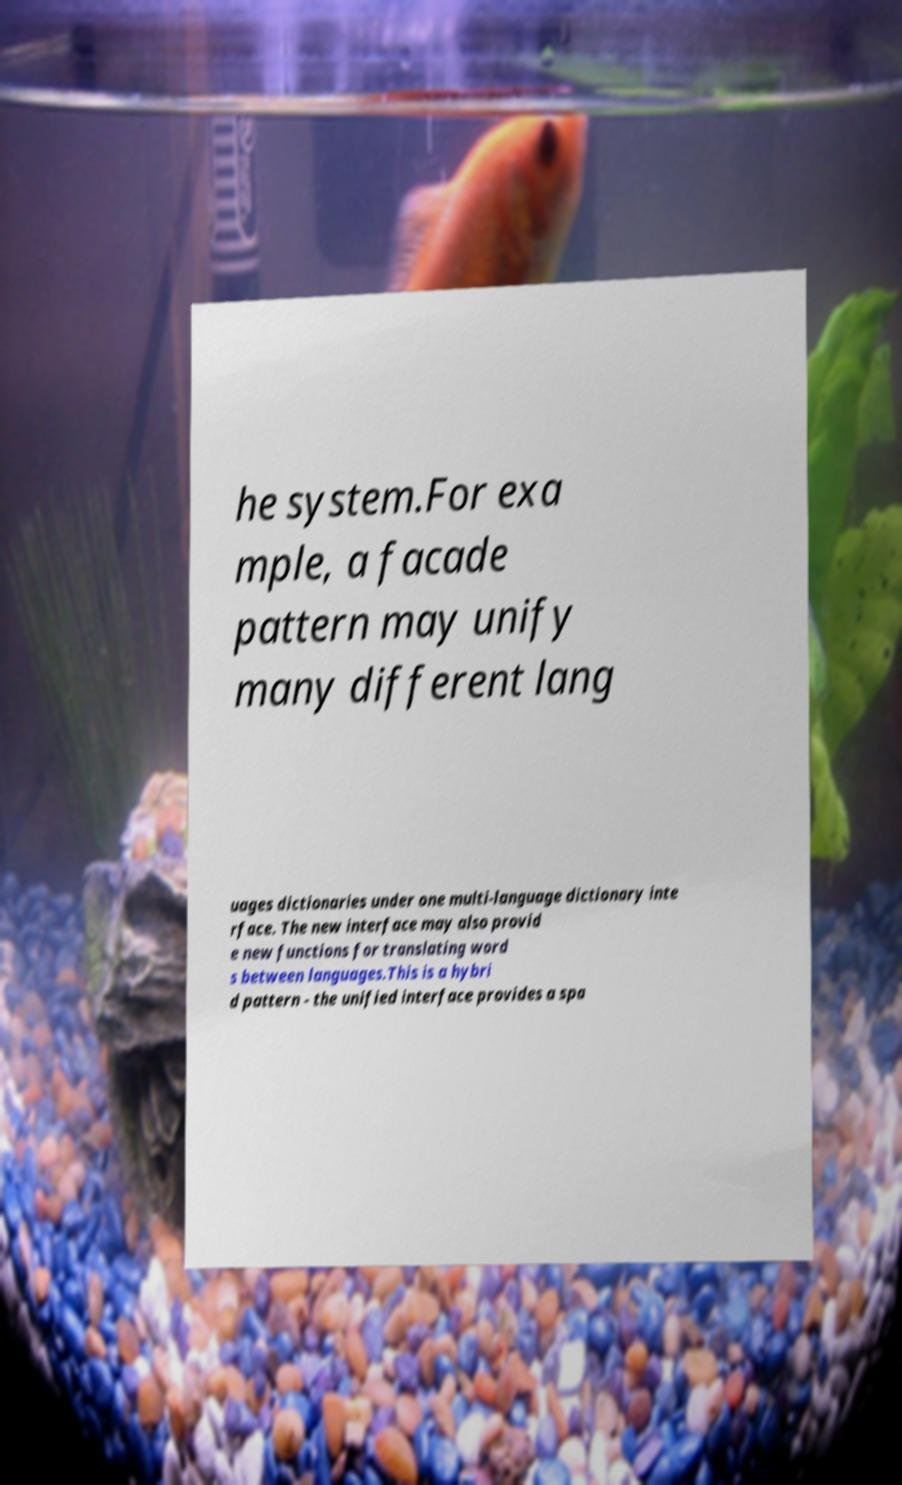Can you accurately transcribe the text from the provided image for me? he system.For exa mple, a facade pattern may unify many different lang uages dictionaries under one multi-language dictionary inte rface. The new interface may also provid e new functions for translating word s between languages.This is a hybri d pattern - the unified interface provides a spa 